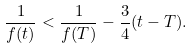Convert formula to latex. <formula><loc_0><loc_0><loc_500><loc_500>\frac { 1 } { f ( t ) } < \frac { 1 } { f ( T ) } - \frac { 3 } { 4 } ( t - T ) .</formula> 